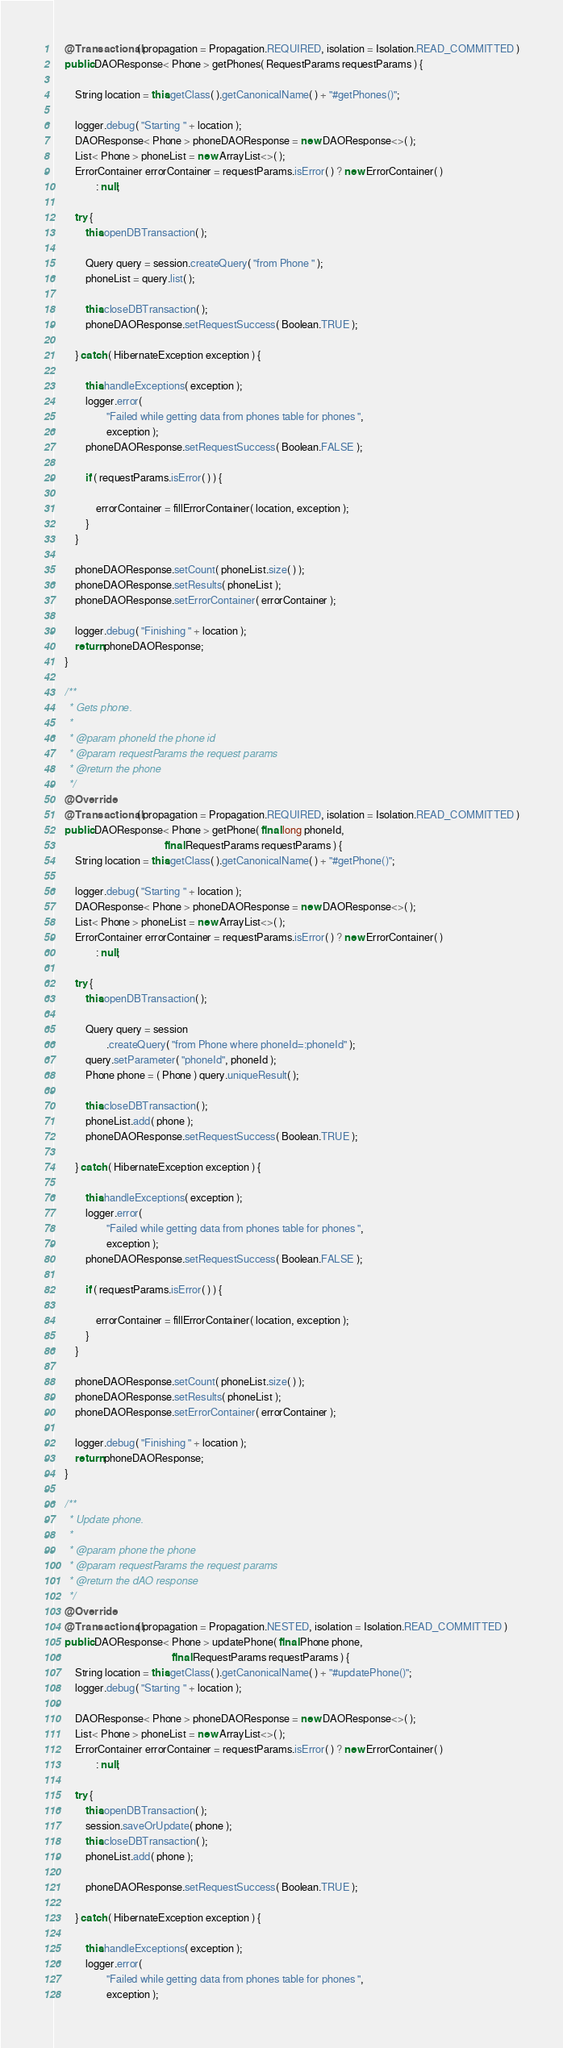Convert code to text. <code><loc_0><loc_0><loc_500><loc_500><_Java_>    @Transactional( propagation = Propagation.REQUIRED, isolation = Isolation.READ_COMMITTED )
    public DAOResponse< Phone > getPhones( RequestParams requestParams ) {

        String location = this.getClass( ).getCanonicalName( ) + "#getPhones()";

        logger.debug( "Starting " + location );
        DAOResponse< Phone > phoneDAOResponse = new DAOResponse<>( );
        List< Phone > phoneList = new ArrayList<>( );
        ErrorContainer errorContainer = requestParams.isError( ) ? new ErrorContainer( )
                : null;

        try {
            this.openDBTransaction( );

            Query query = session.createQuery( "from Phone " );
            phoneList = query.list( );

            this.closeDBTransaction( );
            phoneDAOResponse.setRequestSuccess( Boolean.TRUE );

        } catch ( HibernateException exception ) {

            this.handleExceptions( exception );
            logger.error(
                    "Failed while getting data from phones table for phones ",
                    exception );
            phoneDAOResponse.setRequestSuccess( Boolean.FALSE );

            if ( requestParams.isError( ) ) {

                errorContainer = fillErrorContainer( location, exception );
            }
        }

        phoneDAOResponse.setCount( phoneList.size( ) );
        phoneDAOResponse.setResults( phoneList );
        phoneDAOResponse.setErrorContainer( errorContainer );

        logger.debug( "Finishing " + location );
        return phoneDAOResponse;
    }

    /**
     * Gets phone.
     *
     * @param phoneId the phone id
     * @param requestParams the request params
     * @return the phone
     */
    @Override
    @Transactional( propagation = Propagation.REQUIRED, isolation = Isolation.READ_COMMITTED )
    public DAOResponse< Phone > getPhone( final long phoneId,
                                          final RequestParams requestParams ) {
        String location = this.getClass( ).getCanonicalName( ) + "#getPhone()";

        logger.debug( "Starting " + location );
        DAOResponse< Phone > phoneDAOResponse = new DAOResponse<>( );
        List< Phone > phoneList = new ArrayList<>( );
        ErrorContainer errorContainer = requestParams.isError( ) ? new ErrorContainer( )
                : null;

        try {
            this.openDBTransaction( );

            Query query = session
                    .createQuery( "from Phone where phoneId=:phoneId" );
            query.setParameter( "phoneId", phoneId );
            Phone phone = ( Phone ) query.uniqueResult( );

            this.closeDBTransaction( );
            phoneList.add( phone );
            phoneDAOResponse.setRequestSuccess( Boolean.TRUE );

        } catch ( HibernateException exception ) {

            this.handleExceptions( exception );
            logger.error(
                    "Failed while getting data from phones table for phones ",
                    exception );
            phoneDAOResponse.setRequestSuccess( Boolean.FALSE );

            if ( requestParams.isError( ) ) {

                errorContainer = fillErrorContainer( location, exception );
            }
        }

        phoneDAOResponse.setCount( phoneList.size( ) );
        phoneDAOResponse.setResults( phoneList );
        phoneDAOResponse.setErrorContainer( errorContainer );

        logger.debug( "Finishing " + location );
        return phoneDAOResponse;
    }

    /**
     * Update phone.
     *
     * @param phone the phone
     * @param requestParams the request params
     * @return the dAO response
     */
    @Override
    @Transactional( propagation = Propagation.NESTED, isolation = Isolation.READ_COMMITTED )
    public DAOResponse< Phone > updatePhone( final Phone phone,
                                             final RequestParams requestParams ) {
        String location = this.getClass( ).getCanonicalName( ) + "#updatePhone()";
        logger.debug( "Starting " + location );

        DAOResponse< Phone > phoneDAOResponse = new DAOResponse<>( );
        List< Phone > phoneList = new ArrayList<>( );
        ErrorContainer errorContainer = requestParams.isError( ) ? new ErrorContainer( )
                : null;

        try {
            this.openDBTransaction( );
            session.saveOrUpdate( phone );
            this.closeDBTransaction( );
            phoneList.add( phone );

            phoneDAOResponse.setRequestSuccess( Boolean.TRUE );

        } catch ( HibernateException exception ) {

            this.handleExceptions( exception );
            logger.error(
                    "Failed while getting data from phones table for phones ",
                    exception );</code> 